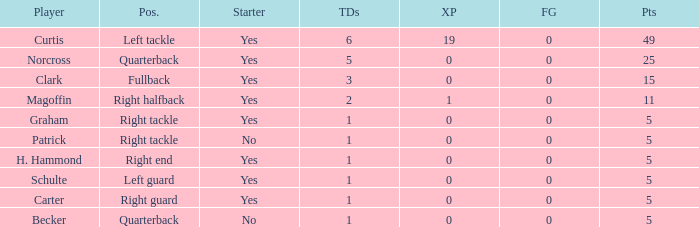Name the most touchdowns for norcross 5.0. 